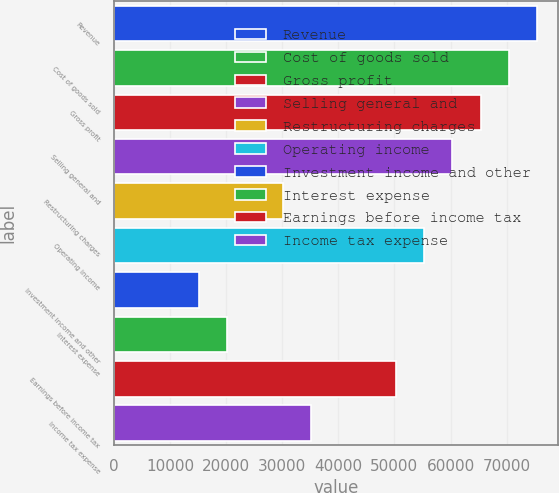Convert chart. <chart><loc_0><loc_0><loc_500><loc_500><bar_chart><fcel>Revenue<fcel>Cost of goods sold<fcel>Gross profit<fcel>Selling general and<fcel>Restructuring charges<fcel>Operating income<fcel>Investment income and other<fcel>Interest expense<fcel>Earnings before income tax<fcel>Income tax expense<nl><fcel>75407<fcel>70380<fcel>65353<fcel>60326<fcel>30164<fcel>55299<fcel>15083<fcel>20110<fcel>50272<fcel>35191<nl></chart> 